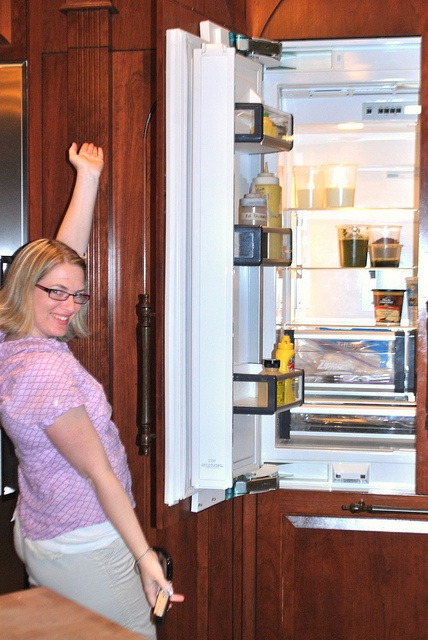Describe the objects in this image and their specific colors. I can see refrigerator in maroon, lightgray, darkgray, and gray tones, people in maroon, darkgray, lightpink, pink, and lavender tones, bottle in maroon, tan, darkgray, and olive tones, bottle in maroon, tan, black, gray, and olive tones, and bottle in maroon, darkgray, and gray tones in this image. 